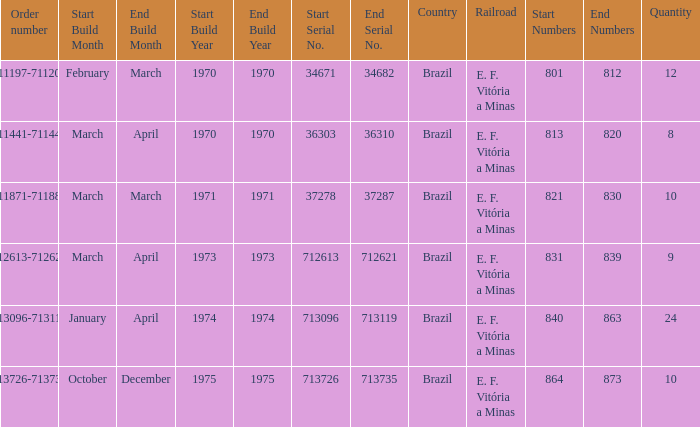How many railroads have the numbers 864-873? 1.0. 